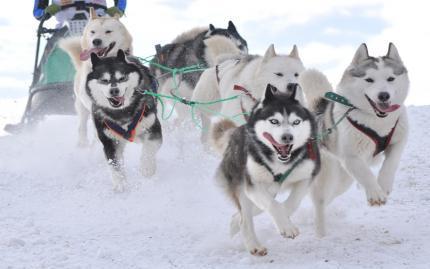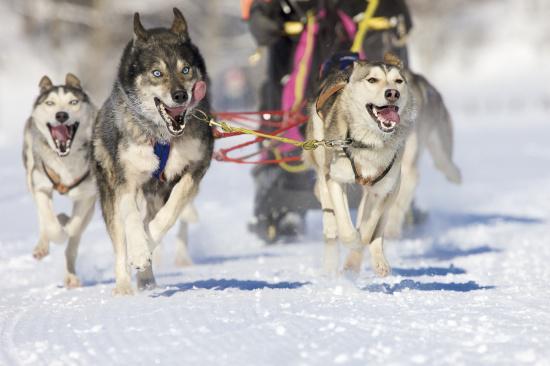The first image is the image on the left, the second image is the image on the right. For the images shown, is this caption "The right image shows a dog team racing forward and toward the right, and the left image shows a dog team that is not moving." true? Answer yes or no. No. 